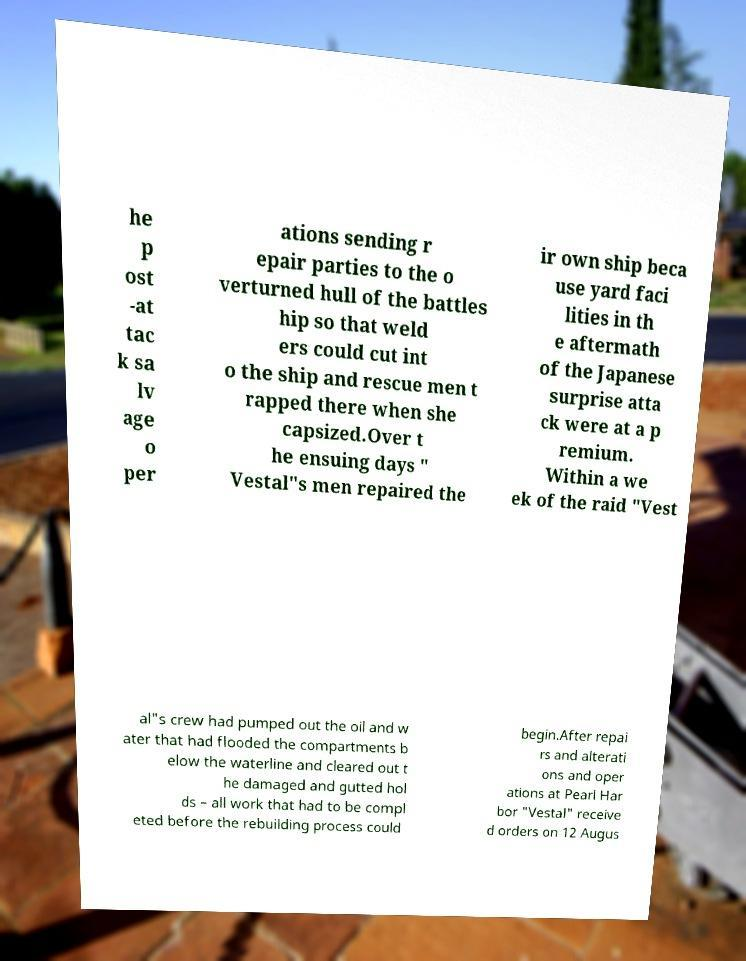Could you assist in decoding the text presented in this image and type it out clearly? he p ost -at tac k sa lv age o per ations sending r epair parties to the o verturned hull of the battles hip so that weld ers could cut int o the ship and rescue men t rapped there when she capsized.Over t he ensuing days " Vestal"s men repaired the ir own ship beca use yard faci lities in th e aftermath of the Japanese surprise atta ck were at a p remium. Within a we ek of the raid "Vest al"s crew had pumped out the oil and w ater that had flooded the compartments b elow the waterline and cleared out t he damaged and gutted hol ds – all work that had to be compl eted before the rebuilding process could begin.After repai rs and alterati ons and oper ations at Pearl Har bor "Vestal" receive d orders on 12 Augus 